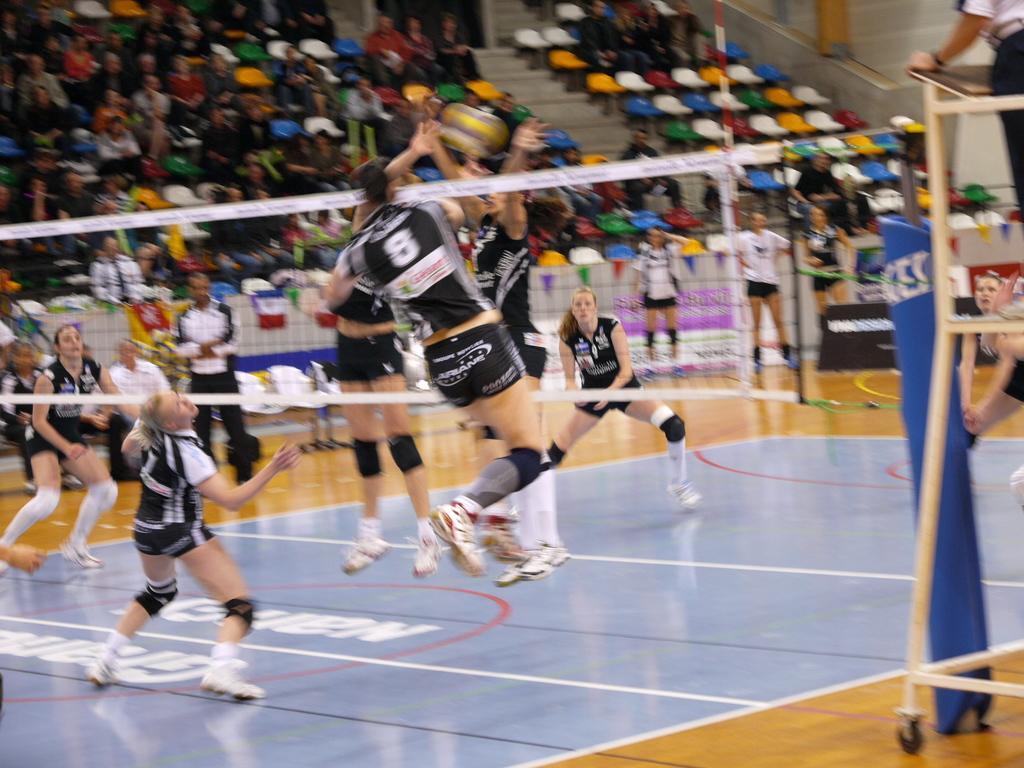Please provide a concise description of this image. In this image I can see there are few people playing throw ball and there are audience sitting in the background and the image is blurred. 